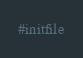<code> <loc_0><loc_0><loc_500><loc_500><_Python_>#initfile
</code> 